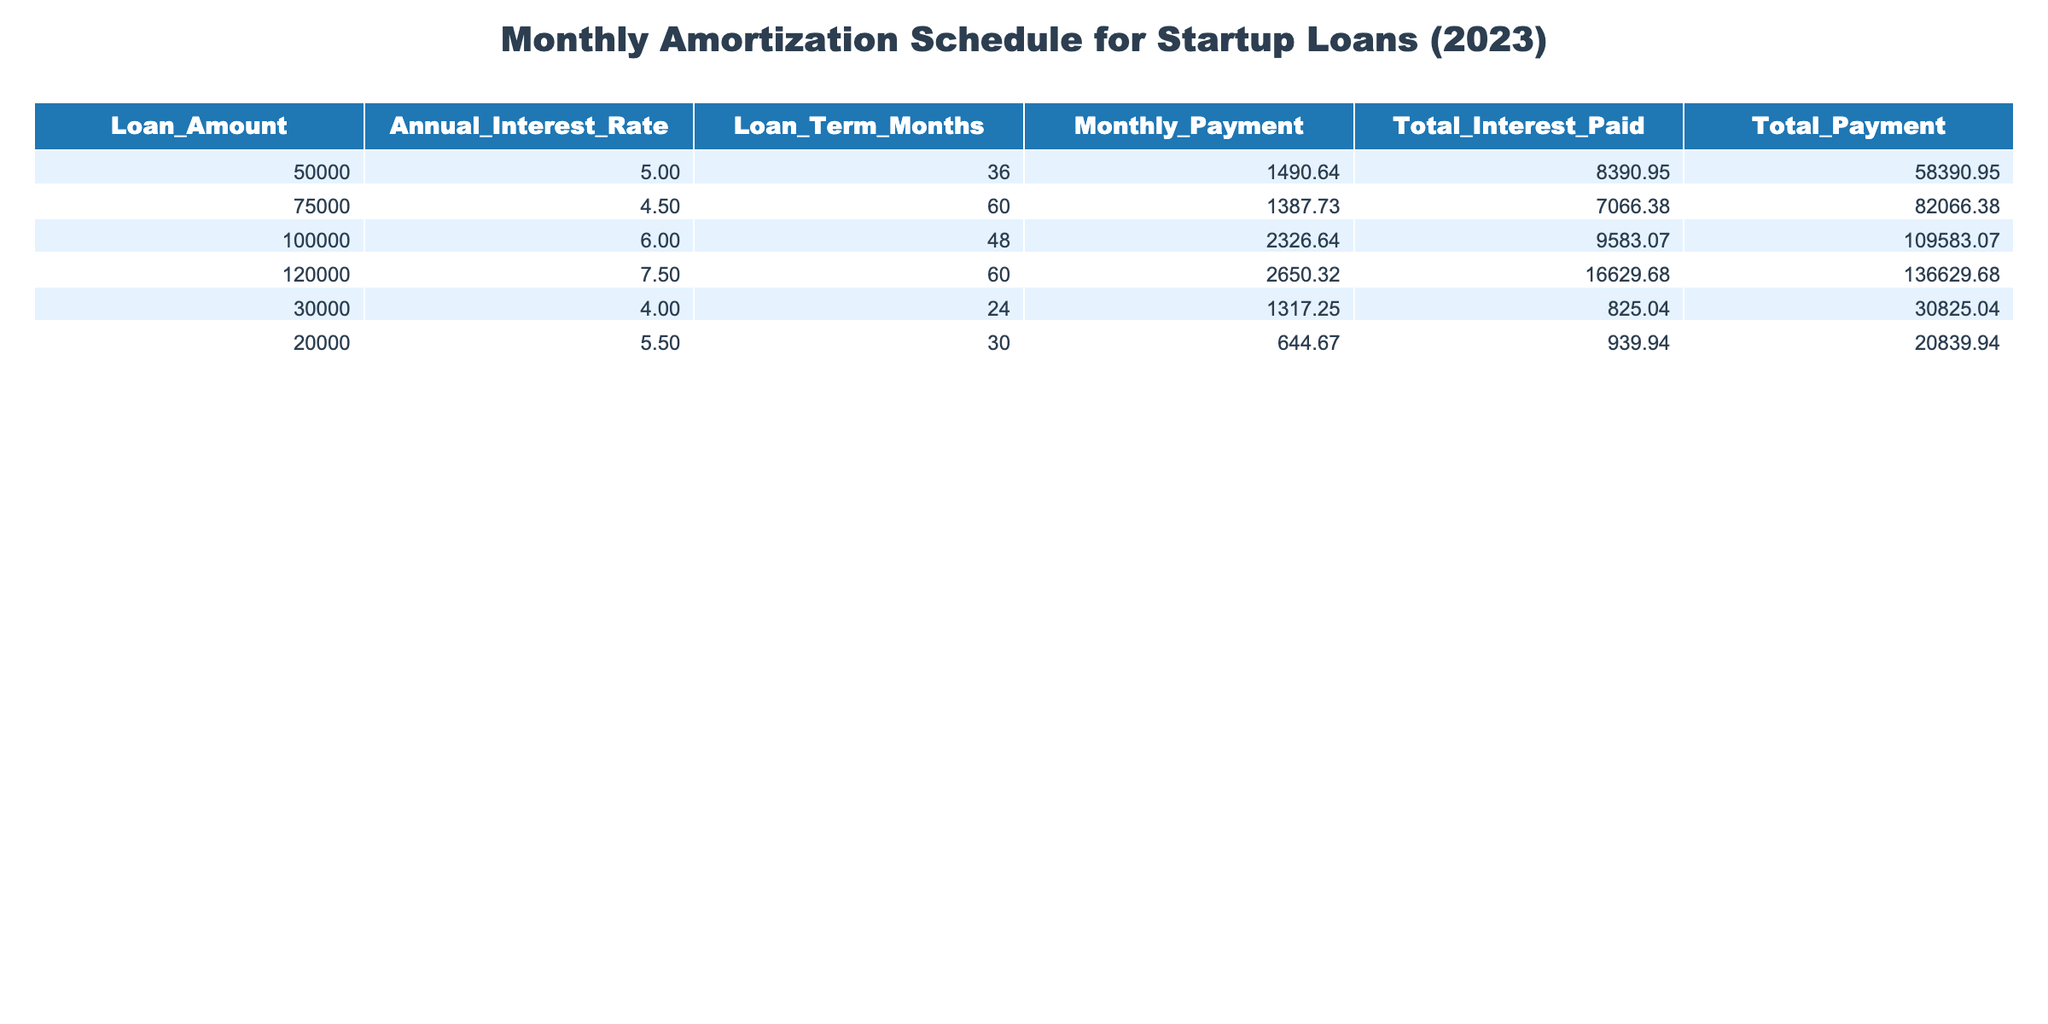What is the total payment for the loan with an amount of 100,000? The total payment for the loan with an amount of 100,000 is provided in the table as 109,583.07.
Answer: 109,583.07 Which loan has the highest monthly payment? By examining the 'Monthly Payment' column, the loan with an amount of 120,000 has the highest monthly payment of 2,650.32.
Answer: 2,650.32 What is the average interest rate of all the loans listed? To find the average interest rate, sum all the interest rates (5.0 + 4.5 + 6.0 + 7.5 + 4.0 + 5.5 = 32.5) and divide by the number of loans (6), giving an average interest rate of 5.42.
Answer: 5.42 Is it true that the loan of 30,000 has a lower total interest paid than the loan of 20,000? The total interest paid for the loan of 30,000 is 825.04, while for the loan of 20,000 it is 939.94. Since 825.04 is less than 939.94, the statement is true.
Answer: Yes How much more total interest is paid on the 120,000 loan compared to the 50,000 loan? The total interest paid on the 120,000 loan is 16,629.68, and for the 50,000 loan, it is 8,390.95. The difference is calculated as 16,629.68 - 8,390.95, which equals 8,238.73.
Answer: 8,238.73 Which loan has the lowest monthly payment, and what is that payment? The 'Monthly Payment' for the loan of 20,000 is 644.67, which is the lowest when compared against other loans.
Answer: 644.67 What percentage of the total payment of the 75,000 loan is made up of interest? The total payment for the 75,000 loan is 82,066.38, and the total interest paid is 7,066.38. To find the percentage, divide the total interest by the total payment (7066.38 / 82066.38) and multiply by 100, yielding approximately 8.60%.
Answer: 8.60% Which loan has a duration of 60 months and what is its total payment? The loans for 60 months are 75,000 and 120,000. The total payment for the 75,000 loan is 82,066.38, and for the 120,000 loan it is 136,629.68.
Answer: 82,066.38 (75,000), 136,629.68 (120,000) 